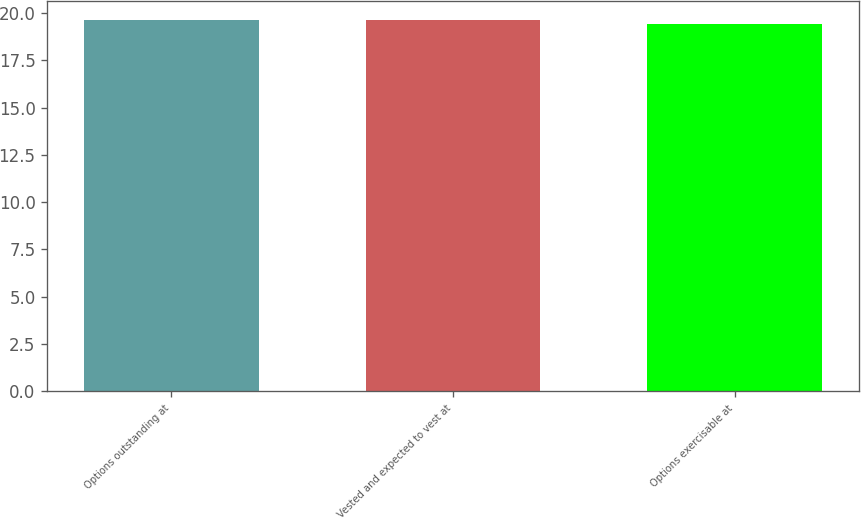<chart> <loc_0><loc_0><loc_500><loc_500><bar_chart><fcel>Options outstanding at<fcel>Vested and expected to vest at<fcel>Options exercisable at<nl><fcel>19.64<fcel>19.66<fcel>19.44<nl></chart> 